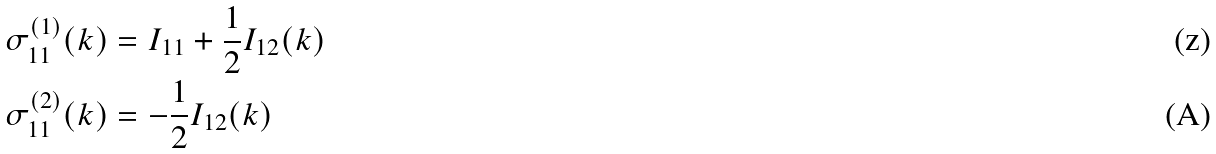Convert formula to latex. <formula><loc_0><loc_0><loc_500><loc_500>& \sigma _ { 1 1 } ^ { ( 1 ) } ( k ) = I _ { 1 1 } + \frac { 1 } { 2 } I _ { 1 2 } ( k ) \\ & \sigma _ { 1 1 } ^ { ( 2 ) } ( k ) = - \frac { 1 } { 2 } I _ { 1 2 } ( k )</formula> 